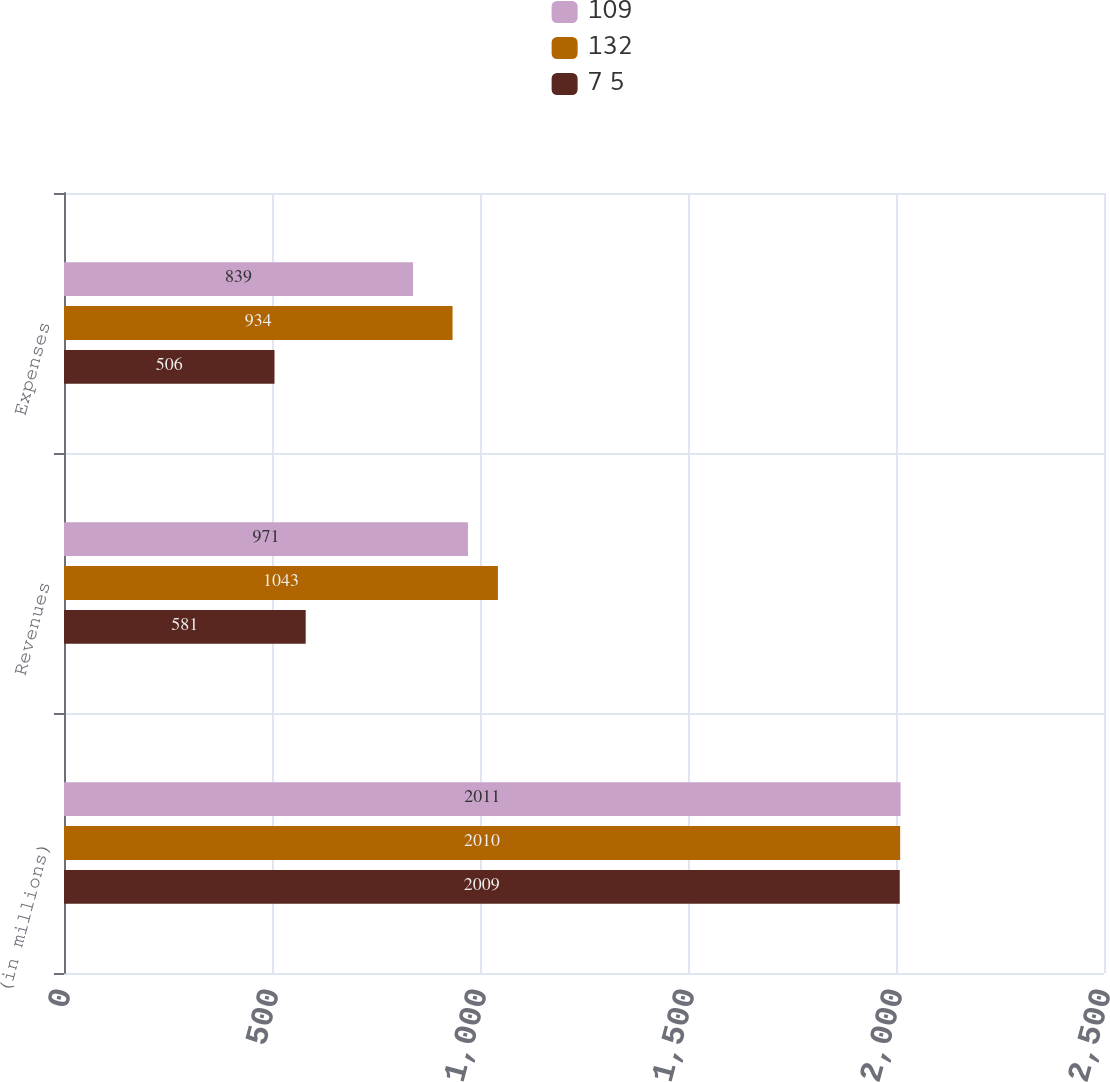Convert chart. <chart><loc_0><loc_0><loc_500><loc_500><stacked_bar_chart><ecel><fcel>(in millions)<fcel>Revenues<fcel>Expenses<nl><fcel>109<fcel>2011<fcel>971<fcel>839<nl><fcel>132<fcel>2010<fcel>1043<fcel>934<nl><fcel>7 5<fcel>2009<fcel>581<fcel>506<nl></chart> 